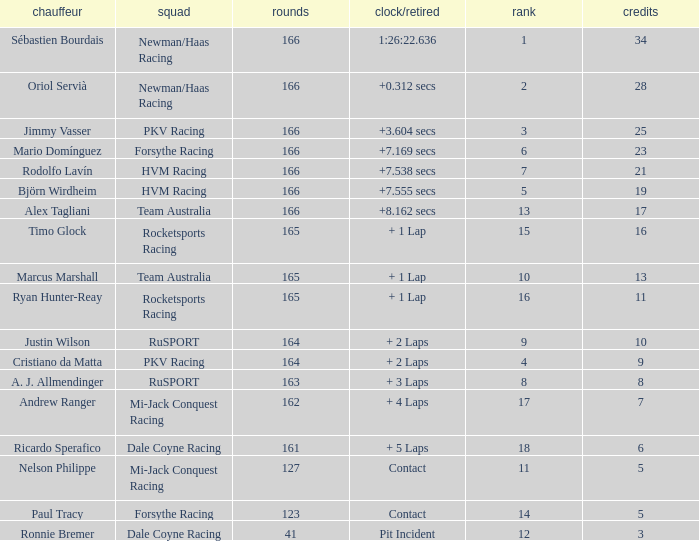What is the average points that the driver Ryan Hunter-Reay has? 11.0. 